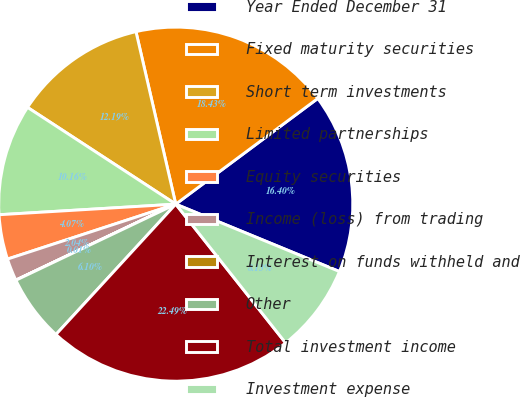<chart> <loc_0><loc_0><loc_500><loc_500><pie_chart><fcel>Year Ended December 31<fcel>Fixed maturity securities<fcel>Short term investments<fcel>Limited partnerships<fcel>Equity securities<fcel>Income (loss) from trading<fcel>Interest on funds withheld and<fcel>Other<fcel>Total investment income<fcel>Investment expense<nl><fcel>16.4%<fcel>18.43%<fcel>12.19%<fcel>10.16%<fcel>4.07%<fcel>2.04%<fcel>0.01%<fcel>6.1%<fcel>22.49%<fcel>8.13%<nl></chart> 